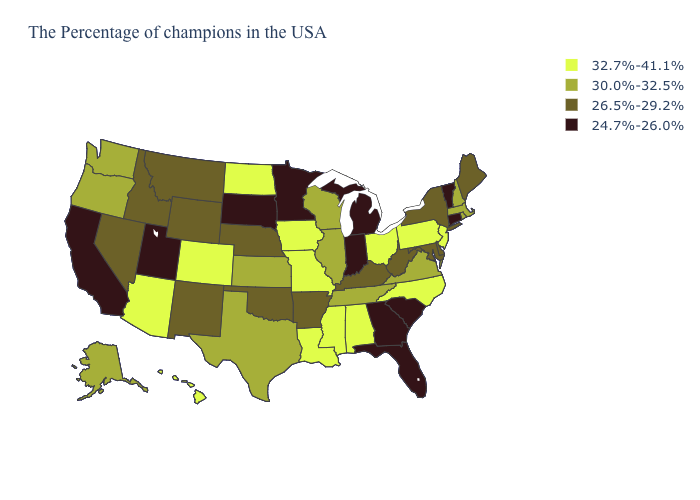Among the states that border Montana , which have the highest value?
Answer briefly. North Dakota. Name the states that have a value in the range 26.5%-29.2%?
Short answer required. Maine, New York, Delaware, Maryland, West Virginia, Kentucky, Arkansas, Nebraska, Oklahoma, Wyoming, New Mexico, Montana, Idaho, Nevada. What is the value of Oklahoma?
Be succinct. 26.5%-29.2%. Does Ohio have the highest value in the MidWest?
Be succinct. Yes. Among the states that border Indiana , which have the lowest value?
Be succinct. Michigan. What is the value of Alaska?
Keep it brief. 30.0%-32.5%. What is the value of Connecticut?
Give a very brief answer. 24.7%-26.0%. Among the states that border New Jersey , does Pennsylvania have the lowest value?
Be succinct. No. Name the states that have a value in the range 26.5%-29.2%?
Give a very brief answer. Maine, New York, Delaware, Maryland, West Virginia, Kentucky, Arkansas, Nebraska, Oklahoma, Wyoming, New Mexico, Montana, Idaho, Nevada. What is the value of Indiana?
Answer briefly. 24.7%-26.0%. What is the value of South Carolina?
Be succinct. 24.7%-26.0%. Name the states that have a value in the range 30.0%-32.5%?
Be succinct. Massachusetts, Rhode Island, New Hampshire, Virginia, Tennessee, Wisconsin, Illinois, Kansas, Texas, Washington, Oregon, Alaska. How many symbols are there in the legend?
Answer briefly. 4. Does Texas have the highest value in the South?
Give a very brief answer. No. What is the value of South Carolina?
Quick response, please. 24.7%-26.0%. 